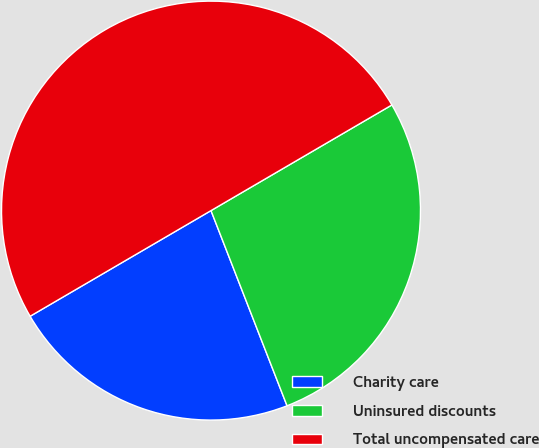Convert chart to OTSL. <chart><loc_0><loc_0><loc_500><loc_500><pie_chart><fcel>Charity care<fcel>Uninsured discounts<fcel>Total uncompensated care<nl><fcel>22.5%<fcel>27.5%<fcel>50.0%<nl></chart> 